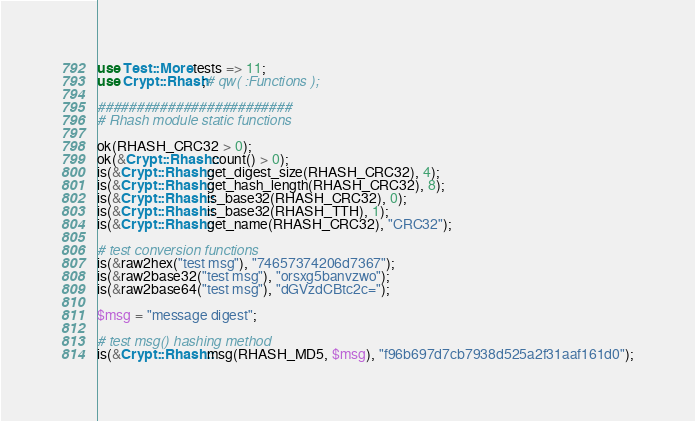Convert code to text. <code><loc_0><loc_0><loc_500><loc_500><_Perl_>use Test::More tests => 11;
use Crypt::Rhash;# qw( :Functions );

#########################
# Rhash module static functions

ok(RHASH_CRC32 > 0);
ok(&Crypt::Rhash::count() > 0);
is(&Crypt::Rhash::get_digest_size(RHASH_CRC32), 4);
is(&Crypt::Rhash::get_hash_length(RHASH_CRC32), 8);
is(&Crypt::Rhash::is_base32(RHASH_CRC32), 0);
is(&Crypt::Rhash::is_base32(RHASH_TTH), 1);
is(&Crypt::Rhash::get_name(RHASH_CRC32), "CRC32");

# test conversion functions
is(&raw2hex("test msg"), "74657374206d7367");
is(&raw2base32("test msg"), "orsxg5banvzwo");
is(&raw2base64("test msg"), "dGVzdCBtc2c=");

$msg = "message digest";

# test msg() hashing method
is(&Crypt::Rhash::msg(RHASH_MD5, $msg), "f96b697d7cb7938d525a2f31aaf161d0");
</code> 